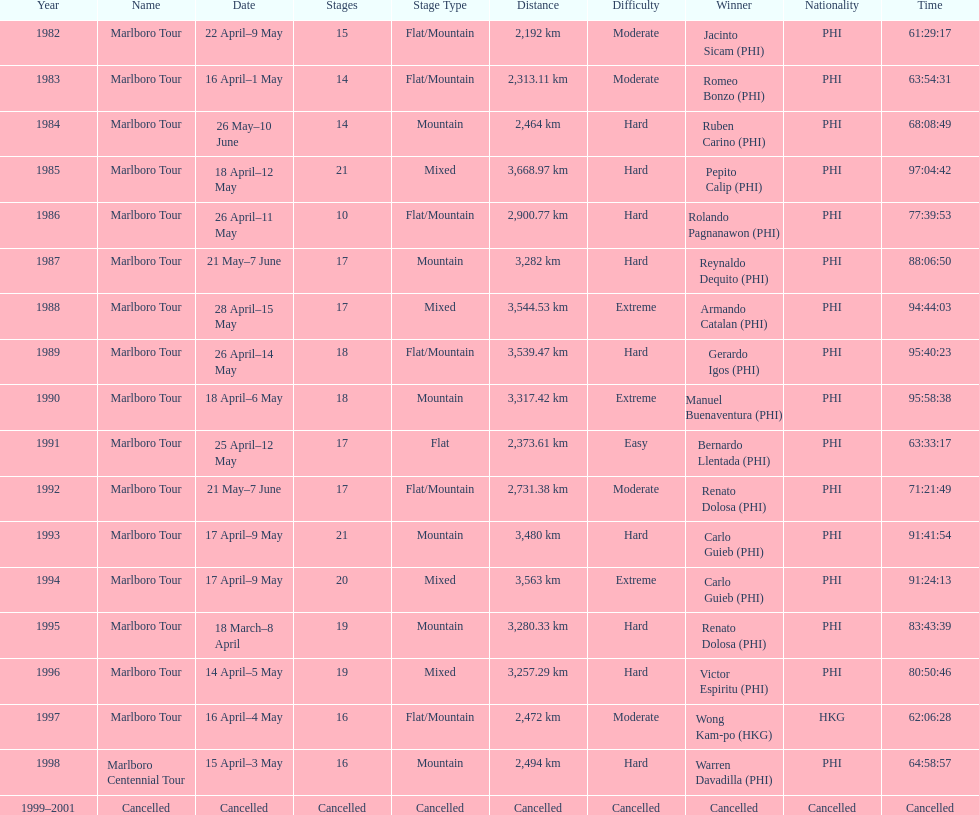Could you help me parse every detail presented in this table? {'header': ['Year', 'Name', 'Date', 'Stages', 'Stage Type', 'Distance', 'Difficulty', 'Winner', 'Nationality', 'Time'], 'rows': [['1982', 'Marlboro Tour', '22 April–9 May', '15', 'Flat/Mountain', '2,192\xa0km', 'Moderate', 'Jacinto Sicam\xa0(PHI)', 'PHI', '61:29:17'], ['1983', 'Marlboro Tour', '16 April–1 May', '14', 'Flat/Mountain', '2,313.11\xa0km', 'Moderate', 'Romeo Bonzo\xa0(PHI)', 'PHI', '63:54:31'], ['1984', 'Marlboro Tour', '26 May–10 June', '14', 'Mountain', '2,464\xa0km', 'Hard', 'Ruben Carino\xa0(PHI)', 'PHI', '68:08:49'], ['1985', 'Marlboro Tour', '18 April–12 May', '21', 'Mixed', '3,668.97\xa0km', 'Hard', 'Pepito Calip\xa0(PHI)', 'PHI', '97:04:42'], ['1986', 'Marlboro Tour', '26 April–11 May', '10', 'Flat/Mountain', '2,900.77\xa0km', 'Hard', 'Rolando Pagnanawon\xa0(PHI)', 'PHI', '77:39:53'], ['1987', 'Marlboro Tour', '21 May–7 June', '17', 'Mountain', '3,282\xa0km', 'Hard', 'Reynaldo Dequito\xa0(PHI)', 'PHI', '88:06:50'], ['1988', 'Marlboro Tour', '28 April–15 May', '17', 'Mixed', '3,544.53\xa0km', 'Extreme', 'Armando Catalan\xa0(PHI)', 'PHI', '94:44:03'], ['1989', 'Marlboro Tour', '26 April–14 May', '18', 'Flat/Mountain', '3,539.47\xa0km', 'Hard', 'Gerardo Igos\xa0(PHI)', 'PHI', '95:40:23'], ['1990', 'Marlboro Tour', '18 April–6 May', '18', 'Mountain', '3,317.42\xa0km', 'Extreme', 'Manuel Buenaventura\xa0(PHI)', 'PHI', '95:58:38'], ['1991', 'Marlboro Tour', '25 April–12 May', '17', 'Flat', '2,373.61\xa0km', 'Easy', 'Bernardo Llentada\xa0(PHI)', 'PHI', '63:33:17'], ['1992', 'Marlboro Tour', '21 May–7 June', '17', 'Flat/Mountain', '2,731.38\xa0km', 'Moderate', 'Renato Dolosa\xa0(PHI)', 'PHI', '71:21:49'], ['1993', 'Marlboro Tour', '17 April–9 May', '21', 'Mountain', '3,480\xa0km', 'Hard', 'Carlo Guieb\xa0(PHI)', 'PHI', '91:41:54'], ['1994', 'Marlboro Tour', '17 April–9 May', '20', 'Mixed', '3,563\xa0km', 'Extreme', 'Carlo Guieb\xa0(PHI)', 'PHI', '91:24:13'], ['1995', 'Marlboro Tour', '18 March–8 April', '19', 'Mountain', '3,280.33\xa0km', 'Hard', 'Renato Dolosa\xa0(PHI)', 'PHI', '83:43:39'], ['1996', 'Marlboro Tour', '14 April–5 May', '19', 'Mixed', '3,257.29\xa0km', 'Hard', 'Victor Espiritu\xa0(PHI)', 'PHI', '80:50:46'], ['1997', 'Marlboro Tour', '16 April–4 May', '16', 'Flat/Mountain', '2,472\xa0km', 'Moderate', 'Wong Kam-po\xa0(HKG)', 'HKG', '62:06:28'], ['1998', 'Marlboro Centennial Tour', '15 April–3 May', '16', 'Mountain', '2,494\xa0km', 'Hard', 'Warren Davadilla\xa0(PHI)', 'PHI', '64:58:57'], ['1999–2001', 'Cancelled', 'Cancelled', 'Cancelled', 'Cancelled', 'Cancelled', 'Cancelled', 'Cancelled', 'Cancelled', 'Cancelled']]} Who is listed before wong kam-po? Victor Espiritu (PHI). 